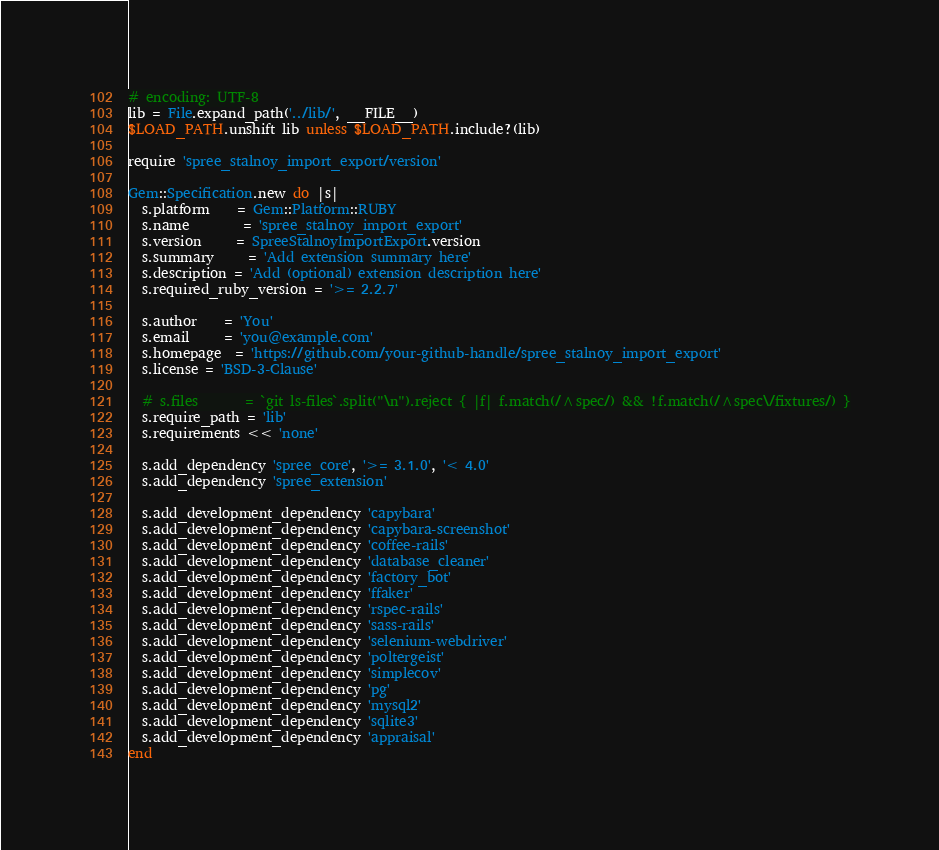<code> <loc_0><loc_0><loc_500><loc_500><_Ruby_># encoding: UTF-8
lib = File.expand_path('../lib/', __FILE__)
$LOAD_PATH.unshift lib unless $LOAD_PATH.include?(lib)

require 'spree_stalnoy_import_export/version'

Gem::Specification.new do |s|
  s.platform    = Gem::Platform::RUBY
  s.name        = 'spree_stalnoy_import_export'
  s.version     = SpreeStalnoyImportExport.version
  s.summary     = 'Add extension summary here'
  s.description = 'Add (optional) extension description here'
  s.required_ruby_version = '>= 2.2.7'

  s.author    = 'You'
  s.email     = 'you@example.com'
  s.homepage  = 'https://github.com/your-github-handle/spree_stalnoy_import_export'
  s.license = 'BSD-3-Clause'

  # s.files       = `git ls-files`.split("\n").reject { |f| f.match(/^spec/) && !f.match(/^spec\/fixtures/) }
  s.require_path = 'lib'
  s.requirements << 'none'

  s.add_dependency 'spree_core', '>= 3.1.0', '< 4.0'
  s.add_dependency 'spree_extension'

  s.add_development_dependency 'capybara'
  s.add_development_dependency 'capybara-screenshot'
  s.add_development_dependency 'coffee-rails'
  s.add_development_dependency 'database_cleaner'
  s.add_development_dependency 'factory_bot'
  s.add_development_dependency 'ffaker'
  s.add_development_dependency 'rspec-rails'
  s.add_development_dependency 'sass-rails'
  s.add_development_dependency 'selenium-webdriver'
  s.add_development_dependency 'poltergeist'
  s.add_development_dependency 'simplecov'
  s.add_development_dependency 'pg'
  s.add_development_dependency 'mysql2'
  s.add_development_dependency 'sqlite3'
  s.add_development_dependency 'appraisal'
end
</code> 